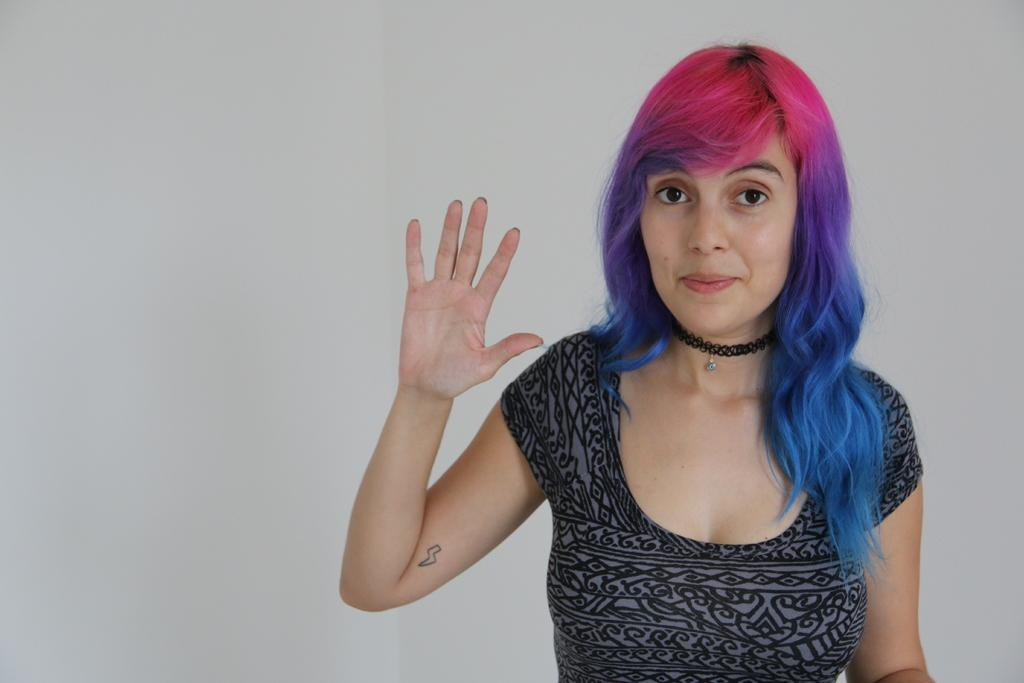What is the main subject in the foreground of the image? There is a woman in the foreground of the image. Can you describe the unclear element in the background of the image? There is an unclear element in the background of the image, which is described as "white in color." How many cherries are on the money in the image? There is no money or cherries present in the image. Is the jam visible in the image? There is no jam present in the image. 